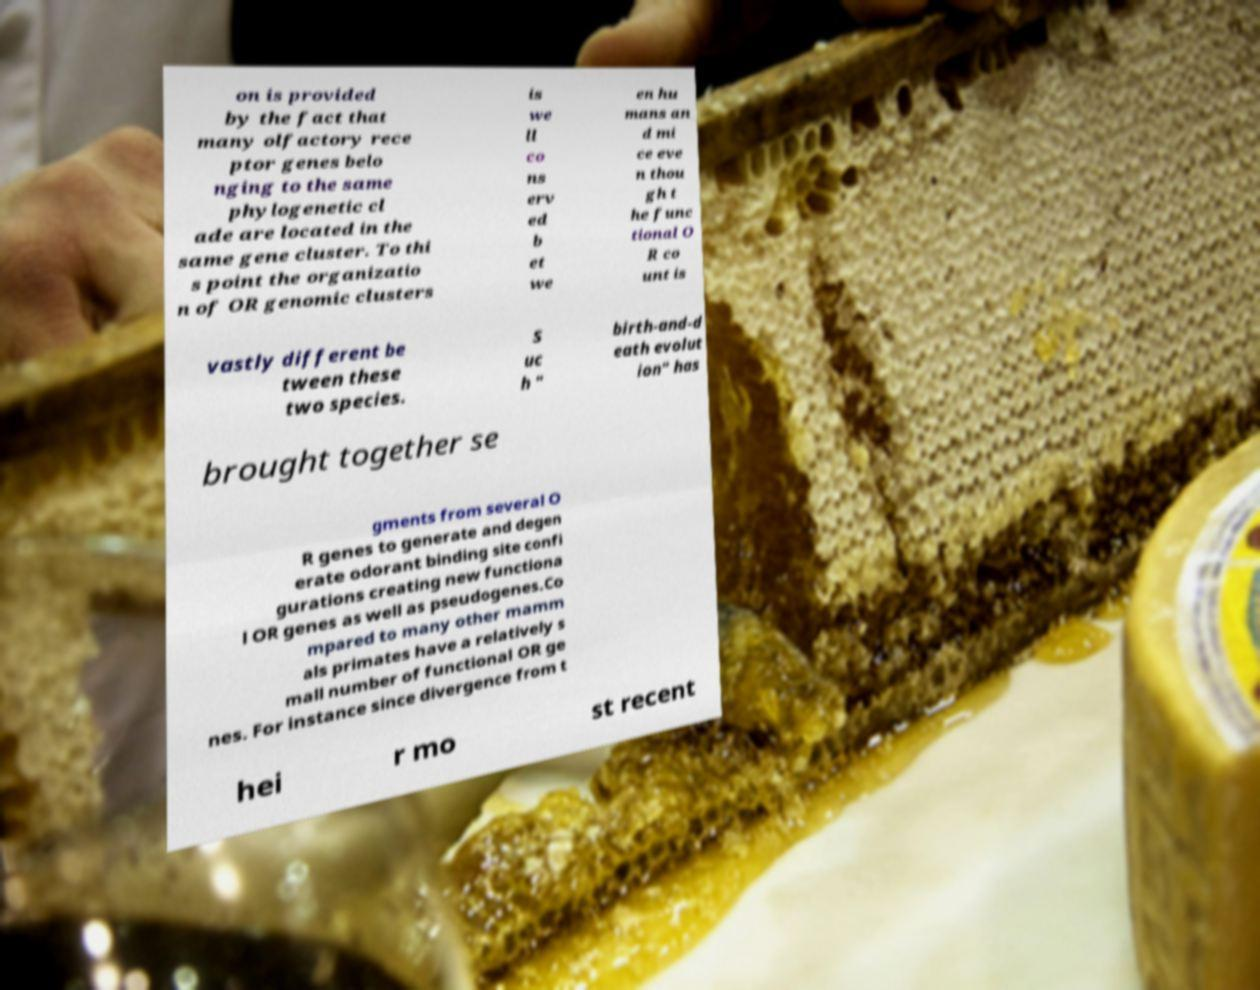There's text embedded in this image that I need extracted. Can you transcribe it verbatim? on is provided by the fact that many olfactory rece ptor genes belo nging to the same phylogenetic cl ade are located in the same gene cluster. To thi s point the organizatio n of OR genomic clusters is we ll co ns erv ed b et we en hu mans an d mi ce eve n thou gh t he func tional O R co unt is vastly different be tween these two species. S uc h " birth-and-d eath evolut ion" has brought together se gments from several O R genes to generate and degen erate odorant binding site confi gurations creating new functiona l OR genes as well as pseudogenes.Co mpared to many other mamm als primates have a relatively s mall number of functional OR ge nes. For instance since divergence from t hei r mo st recent 